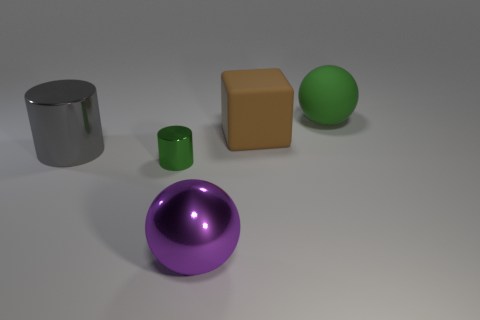Add 2 green matte spheres. How many objects exist? 7 Subtract all spheres. How many objects are left? 3 Subtract all blue matte cylinders. Subtract all green spheres. How many objects are left? 4 Add 4 cylinders. How many cylinders are left? 6 Add 5 brown metal things. How many brown metal things exist? 5 Subtract 0 gray blocks. How many objects are left? 5 